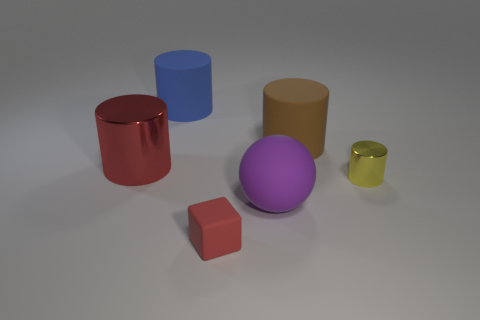Add 2 small green metallic objects. How many objects exist? 8 Subtract all blocks. How many objects are left? 5 Subtract all tiny red rubber blocks. Subtract all cyan cylinders. How many objects are left? 5 Add 5 brown matte cylinders. How many brown matte cylinders are left? 6 Add 1 cyan cubes. How many cyan cubes exist? 1 Subtract 0 green cylinders. How many objects are left? 6 